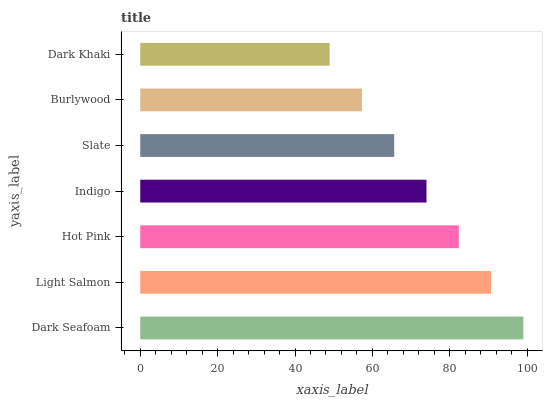Is Dark Khaki the minimum?
Answer yes or no. Yes. Is Dark Seafoam the maximum?
Answer yes or no. Yes. Is Light Salmon the minimum?
Answer yes or no. No. Is Light Salmon the maximum?
Answer yes or no. No. Is Dark Seafoam greater than Light Salmon?
Answer yes or no. Yes. Is Light Salmon less than Dark Seafoam?
Answer yes or no. Yes. Is Light Salmon greater than Dark Seafoam?
Answer yes or no. No. Is Dark Seafoam less than Light Salmon?
Answer yes or no. No. Is Indigo the high median?
Answer yes or no. Yes. Is Indigo the low median?
Answer yes or no. Yes. Is Slate the high median?
Answer yes or no. No. Is Hot Pink the low median?
Answer yes or no. No. 